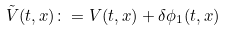Convert formula to latex. <formula><loc_0><loc_0><loc_500><loc_500>\tilde { V } ( t , x ) \colon = V ( t , x ) + \delta \phi _ { 1 } ( t , x )</formula> 